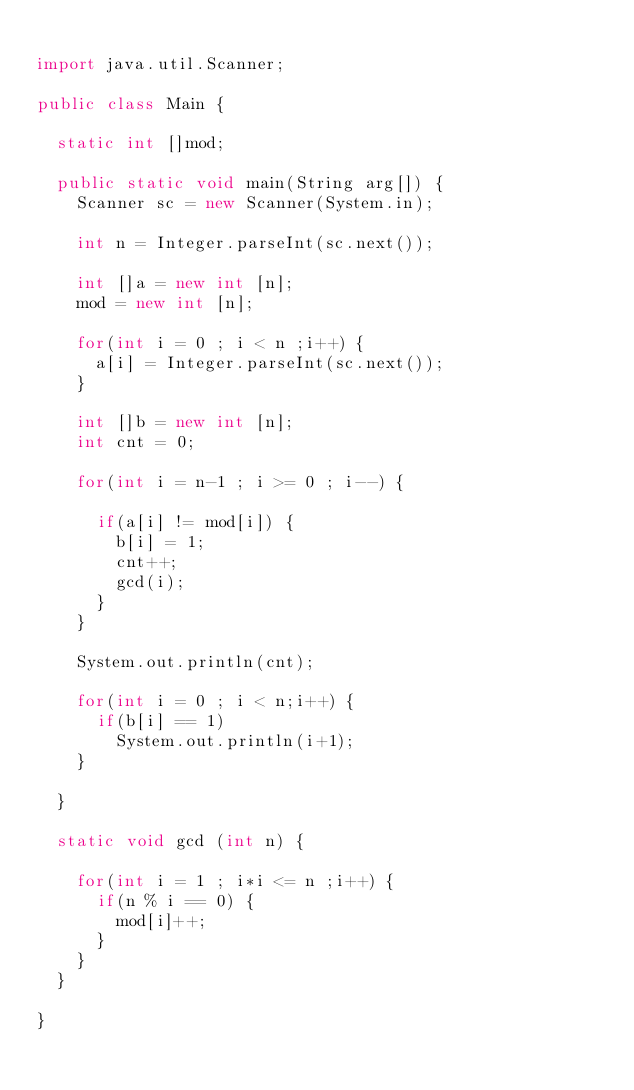Convert code to text. <code><loc_0><loc_0><loc_500><loc_500><_Java_>
import java.util.Scanner;

public class Main {
	
	static int []mod;
	
	public static void main(String arg[]) {
		Scanner sc = new Scanner(System.in);
		
		int n = Integer.parseInt(sc.next());
		
		int []a = new int [n];
		mod = new int [n];
		
		for(int i = 0 ; i < n ;i++) {
			a[i] = Integer.parseInt(sc.next());
		}
		
		int []b = new int [n];
		int cnt = 0;
		
		for(int i = n-1 ; i >= 0 ; i--) {
			
			if(a[i] != mod[i]) {
				b[i] = 1;
				cnt++;
				gcd(i);
			}	
		}
		
		System.out.println(cnt);
		
		for(int i = 0 ; i < n;i++) {
			if(b[i] == 1)
				System.out.println(i+1);
		}
		
	}
	
	static void gcd (int n) {
		
		for(int i = 1 ; i*i <= n ;i++) {
			if(n % i == 0) {
				mod[i]++;
			}
		}
	}
	
}


</code> 